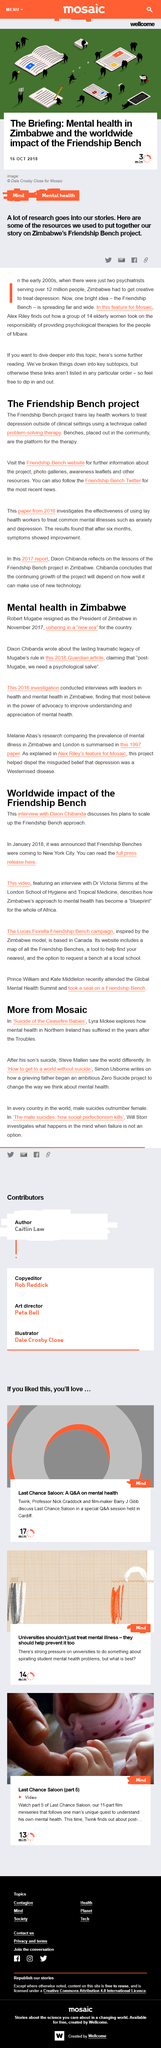Outline some significant characteristics in this image. The Friendship Bench project in Zimbabwe has photos available on the project's website, which can be accessed to view photo galleries. The Friendship Bench project is a non-clinical treatment program for depression that utilizes problem-solving therapy, trained lay health workers, and an outdoor bench as a meeting place to deliver the treatment. Yes, this article is shareable on Facebook and Twitter. The article concerns the mental aspect of health, specifically addressing the various factors that impact an individual's mental well-being. According to the article "Mental Health in Zimbabwe," Robert Mugabe resigned as President of Zimbabwe in November 2017. 